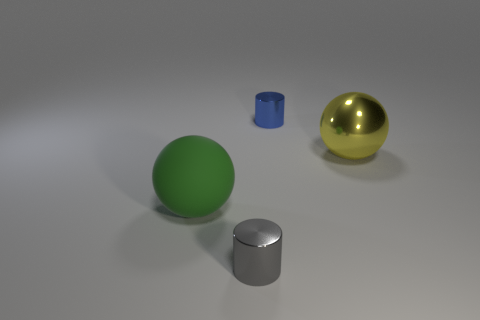Subtract 1 spheres. How many spheres are left? 1 Subtract all green cylinders. Subtract all green balls. How many cylinders are left? 2 Subtract all purple cubes. How many yellow spheres are left? 1 Subtract all tiny cyan rubber cylinders. Subtract all large things. How many objects are left? 2 Add 3 large yellow metal objects. How many large yellow metal objects are left? 4 Add 2 large yellow objects. How many large yellow objects exist? 3 Add 1 tiny objects. How many objects exist? 5 Subtract 1 yellow balls. How many objects are left? 3 